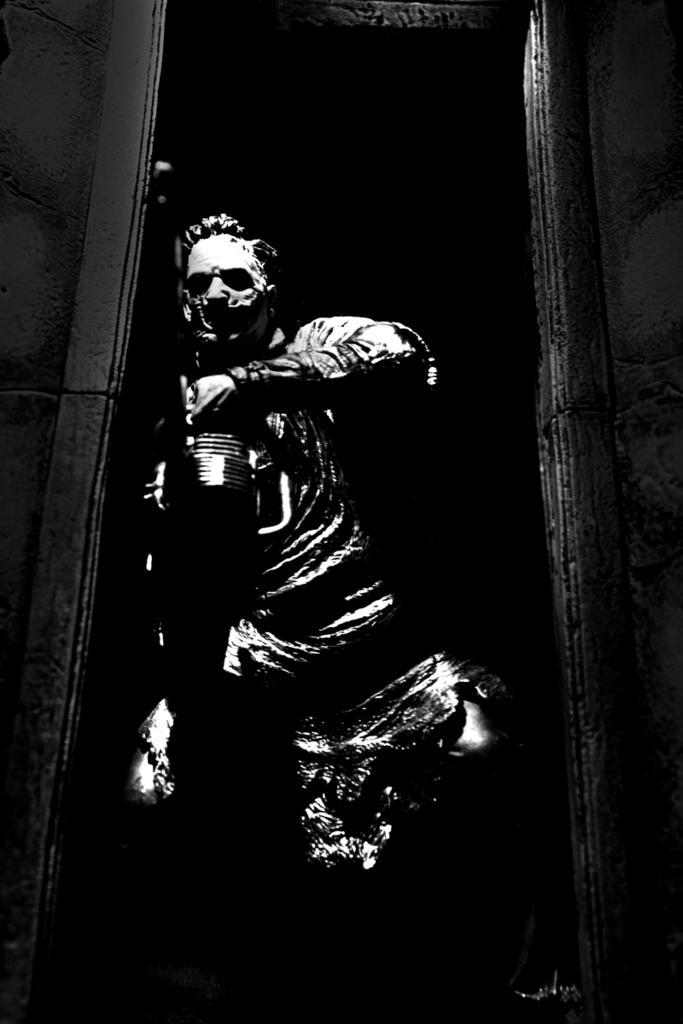Describe this image in one or two sentences. In this image in the center there is a statue. On the right side there is a door. 